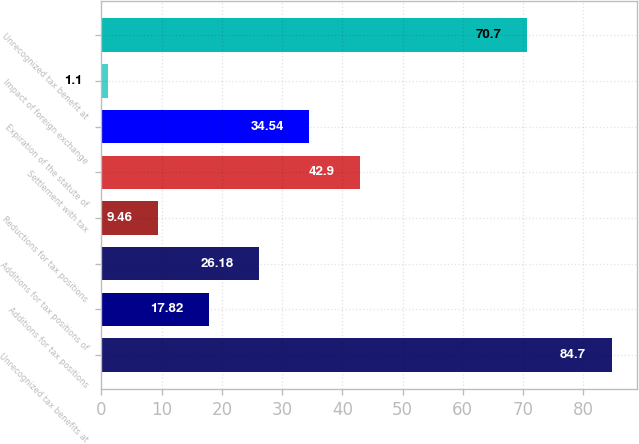Convert chart. <chart><loc_0><loc_0><loc_500><loc_500><bar_chart><fcel>Unrecognized tax benefits at<fcel>Additions for tax positions<fcel>Additions for tax positions of<fcel>Reductions for tax positions<fcel>Settlement with tax<fcel>Expiration of the statute of<fcel>Impact of foreign exchange<fcel>Unrecognized tax benefit at<nl><fcel>84.7<fcel>17.82<fcel>26.18<fcel>9.46<fcel>42.9<fcel>34.54<fcel>1.1<fcel>70.7<nl></chart> 